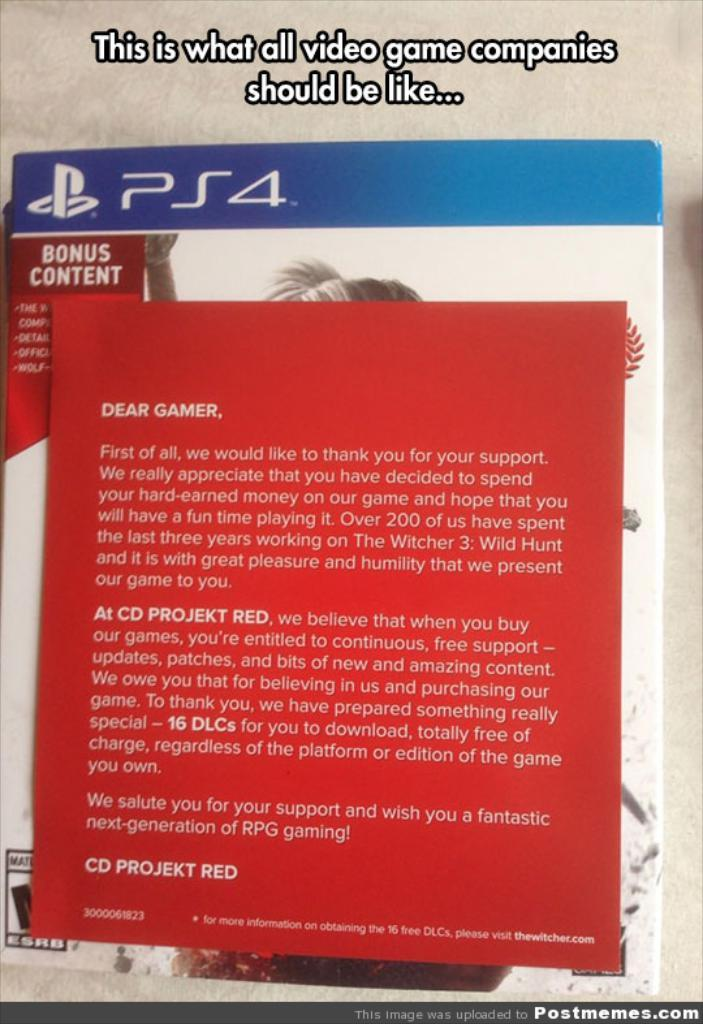<image>
Share a concise interpretation of the image provided. A book about PS4 has a note on top of it that starts with "Dear Gamer". 